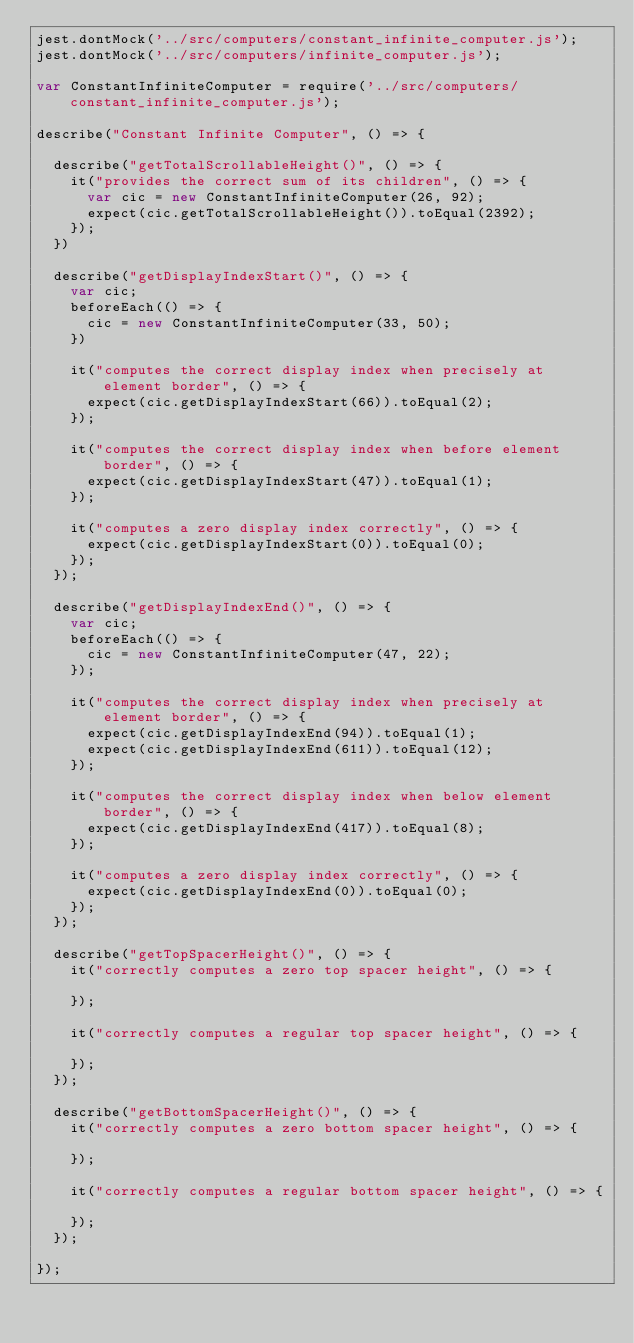Convert code to text. <code><loc_0><loc_0><loc_500><loc_500><_JavaScript_>jest.dontMock('../src/computers/constant_infinite_computer.js');
jest.dontMock('../src/computers/infinite_computer.js');

var ConstantInfiniteComputer = require('../src/computers/constant_infinite_computer.js');

describe("Constant Infinite Computer", () => {

  describe("getTotalScrollableHeight()", () => {
    it("provides the correct sum of its children", () => {
      var cic = new ConstantInfiniteComputer(26, 92);
      expect(cic.getTotalScrollableHeight()).toEqual(2392);
    });
  })

  describe("getDisplayIndexStart()", () => {
    var cic;
    beforeEach(() => {
      cic = new ConstantInfiniteComputer(33, 50);
    })

    it("computes the correct display index when precisely at element border", () => {
      expect(cic.getDisplayIndexStart(66)).toEqual(2);
    });

    it("computes the correct display index when before element border", () => {
      expect(cic.getDisplayIndexStart(47)).toEqual(1);
    });

    it("computes a zero display index correctly", () => {
      expect(cic.getDisplayIndexStart(0)).toEqual(0);
    });
  });

  describe("getDisplayIndexEnd()", () => {
    var cic;
    beforeEach(() => {
      cic = new ConstantInfiniteComputer(47, 22);
    });

    it("computes the correct display index when precisely at element border", () => {
      expect(cic.getDisplayIndexEnd(94)).toEqual(1);
      expect(cic.getDisplayIndexEnd(611)).toEqual(12);
    });

    it("computes the correct display index when below element border", () => {
      expect(cic.getDisplayIndexEnd(417)).toEqual(8);
    });

    it("computes a zero display index correctly", () => {
      expect(cic.getDisplayIndexEnd(0)).toEqual(0);
    });
  });

  describe("getTopSpacerHeight()", () => {
    it("correctly computes a zero top spacer height", () => {

    });

    it("correctly computes a regular top spacer height", () => {

    });
  });

  describe("getBottomSpacerHeight()", () => {
    it("correctly computes a zero bottom spacer height", () => {

    });

    it("correctly computes a regular bottom spacer height", () => {

    });
  });

});
</code> 